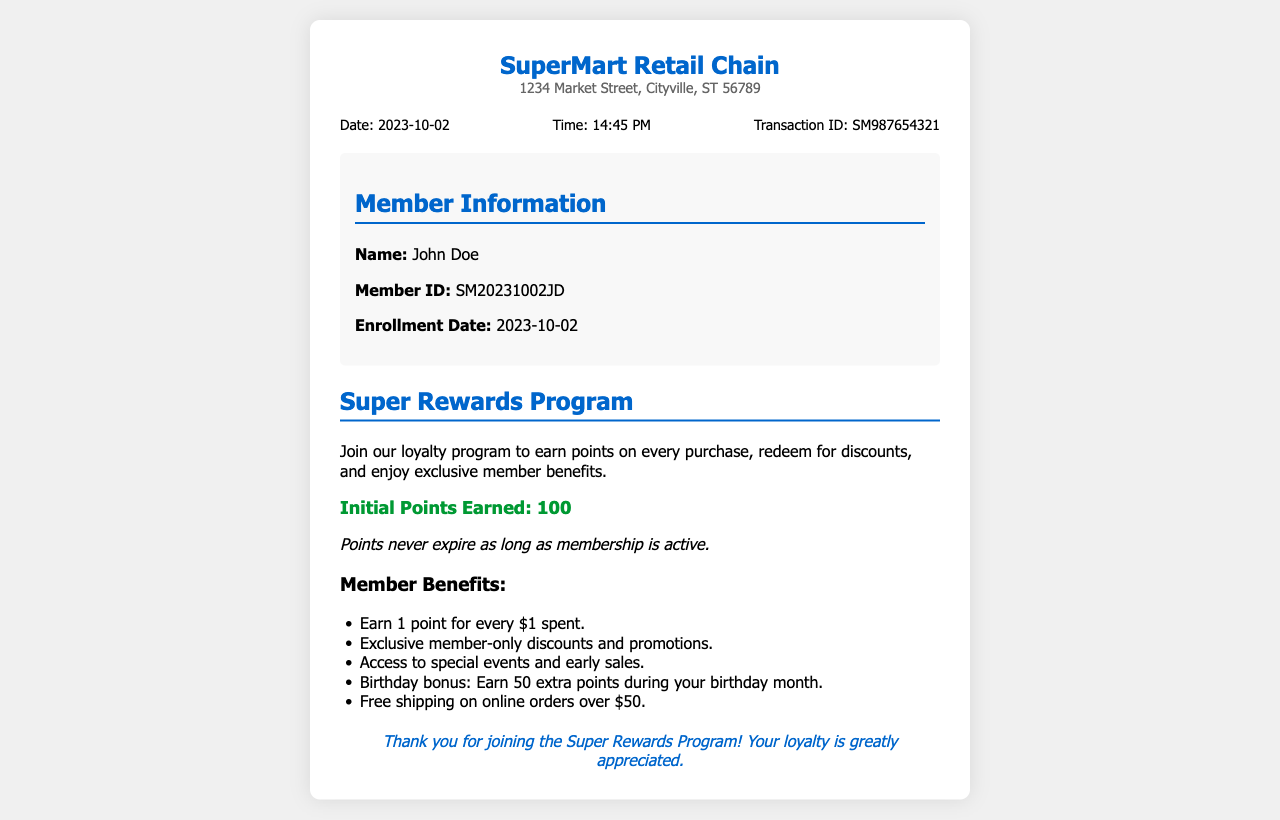What is the transaction ID? The transaction ID is provided in the document under the transaction information section.
Answer: SM987654321 What is the enrollment date? The enrollment date is mentioned in the customer information section of the document.
Answer: 2023-10-02 What are the initial points earned? The document specifies the initial points earned for joining the loyalty program.
Answer: 100 What is the name of the loyalty program? The name of the loyalty program is indicated clearly in the program information section.
Answer: Super Rewards Program How many extra points do members earn during their birthday month? The document states that members receive a bonus during their birthday month, which is described in the benefits list.
Answer: 50 extra points What is the main benefit of the loyalty program? The main benefit is described in the first line of the program description, focusing on earning points from purchases.
Answer: Earn points on every purchase What is the location of the store? The store's address is included in the header section of the receipt.
Answer: 1234 Market Street, Cityville, ST 56789 What time was the transaction completed? The time of the transaction is listed in the transaction information part of the document.
Answer: 14:45 PM 